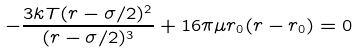Convert formula to latex. <formula><loc_0><loc_0><loc_500><loc_500>- \frac { 3 k T ( r - \sigma / 2 ) ^ { 2 } } { ( r - \sigma / 2 ) ^ { 3 } } + 1 6 \pi \mu r _ { 0 } ( r - r _ { 0 } ) = 0</formula> 